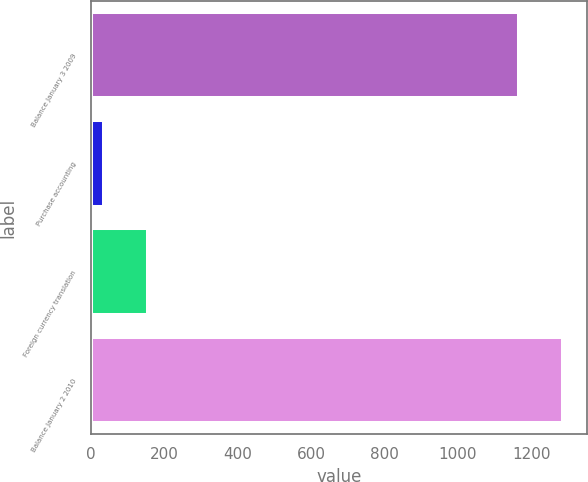Convert chart. <chart><loc_0><loc_0><loc_500><loc_500><bar_chart><fcel>Balance January 3 2009<fcel>Purchase accounting<fcel>Foreign currency translation<fcel>Balance January 2 2010<nl><fcel>1166.1<fcel>36.2<fcel>156.98<fcel>1286.88<nl></chart> 